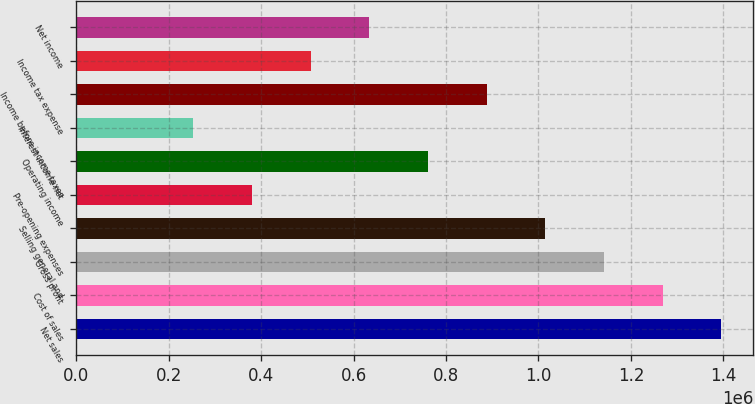Convert chart to OTSL. <chart><loc_0><loc_0><loc_500><loc_500><bar_chart><fcel>Net sales<fcel>Cost of sales<fcel>Gross profit<fcel>Selling general and<fcel>Pre-opening expenses<fcel>Operating income<fcel>Interest income net<fcel>Income before income taxes<fcel>Income tax expense<fcel>Net income<nl><fcel>1.39512e+06<fcel>1.26829e+06<fcel>1.14147e+06<fcel>1.01464e+06<fcel>380490<fcel>760978<fcel>253660<fcel>887807<fcel>507319<fcel>634148<nl></chart> 